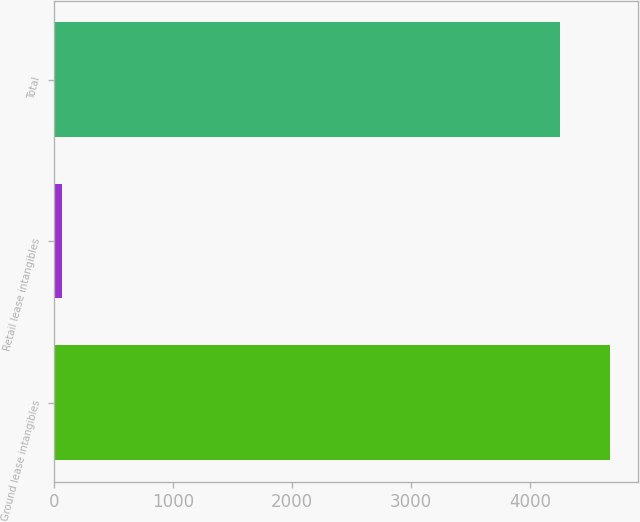Convert chart to OTSL. <chart><loc_0><loc_0><loc_500><loc_500><bar_chart><fcel>Ground lease intangibles<fcel>Retail lease intangibles<fcel>Total<nl><fcel>4675<fcel>71<fcel>4250<nl></chart> 